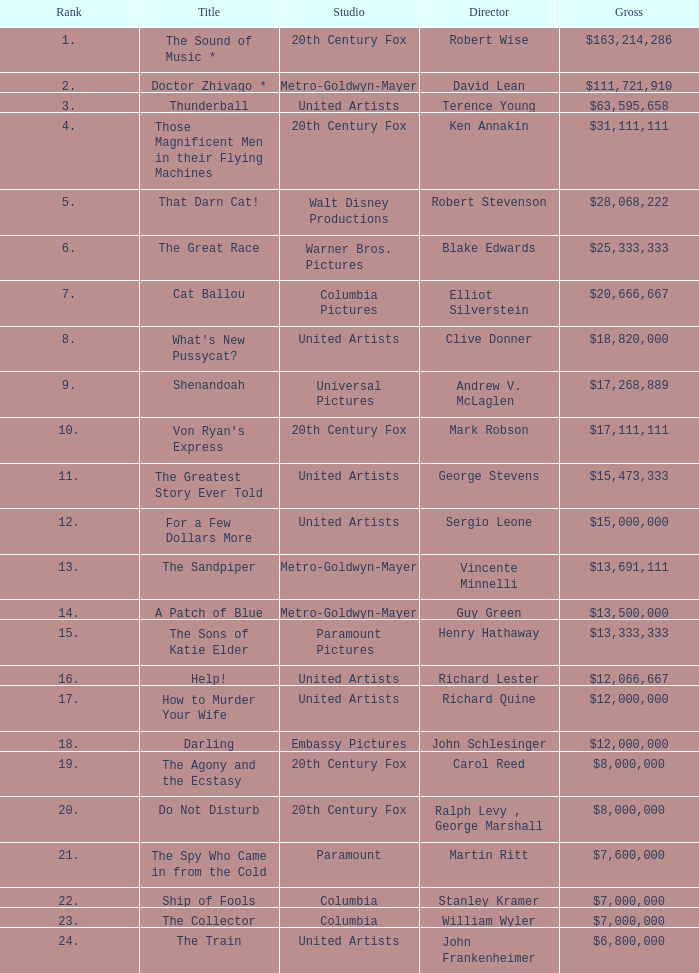What is the highest Rank, when Director is "Henry Hathaway"? 15.0. Parse the table in full. {'header': ['Rank', 'Title', 'Studio', 'Director', 'Gross'], 'rows': [['1.', 'The Sound of Music *', '20th Century Fox', 'Robert Wise', '$163,214,286'], ['2.', 'Doctor Zhivago *', 'Metro-Goldwyn-Mayer', 'David Lean', '$111,721,910'], ['3.', 'Thunderball', 'United Artists', 'Terence Young', '$63,595,658'], ['4.', 'Those Magnificent Men in their Flying Machines', '20th Century Fox', 'Ken Annakin', '$31,111,111'], ['5.', 'That Darn Cat!', 'Walt Disney Productions', 'Robert Stevenson', '$28,068,222'], ['6.', 'The Great Race', 'Warner Bros. Pictures', 'Blake Edwards', '$25,333,333'], ['7.', 'Cat Ballou', 'Columbia Pictures', 'Elliot Silverstein', '$20,666,667'], ['8.', "What's New Pussycat?", 'United Artists', 'Clive Donner', '$18,820,000'], ['9.', 'Shenandoah', 'Universal Pictures', 'Andrew V. McLaglen', '$17,268,889'], ['10.', "Von Ryan's Express", '20th Century Fox', 'Mark Robson', '$17,111,111'], ['11.', 'The Greatest Story Ever Told', 'United Artists', 'George Stevens', '$15,473,333'], ['12.', 'For a Few Dollars More', 'United Artists', 'Sergio Leone', '$15,000,000'], ['13.', 'The Sandpiper', 'Metro-Goldwyn-Mayer', 'Vincente Minnelli', '$13,691,111'], ['14.', 'A Patch of Blue', 'Metro-Goldwyn-Mayer', 'Guy Green', '$13,500,000'], ['15.', 'The Sons of Katie Elder', 'Paramount Pictures', 'Henry Hathaway', '$13,333,333'], ['16.', 'Help!', 'United Artists', 'Richard Lester', '$12,066,667'], ['17.', 'How to Murder Your Wife', 'United Artists', 'Richard Quine', '$12,000,000'], ['18.', 'Darling', 'Embassy Pictures', 'John Schlesinger', '$12,000,000'], ['19.', 'The Agony and the Ecstasy', '20th Century Fox', 'Carol Reed', '$8,000,000'], ['20.', 'Do Not Disturb', '20th Century Fox', 'Ralph Levy , George Marshall', '$8,000,000'], ['21.', 'The Spy Who Came in from the Cold', 'Paramount', 'Martin Ritt', '$7,600,000'], ['22.', 'Ship of Fools', 'Columbia', 'Stanley Kramer', '$7,000,000'], ['23.', 'The Collector', 'Columbia', 'William Wyler', '$7,000,000'], ['24.', 'The Train', 'United Artists', 'John Frankenheimer', '$6,800,000']]} 